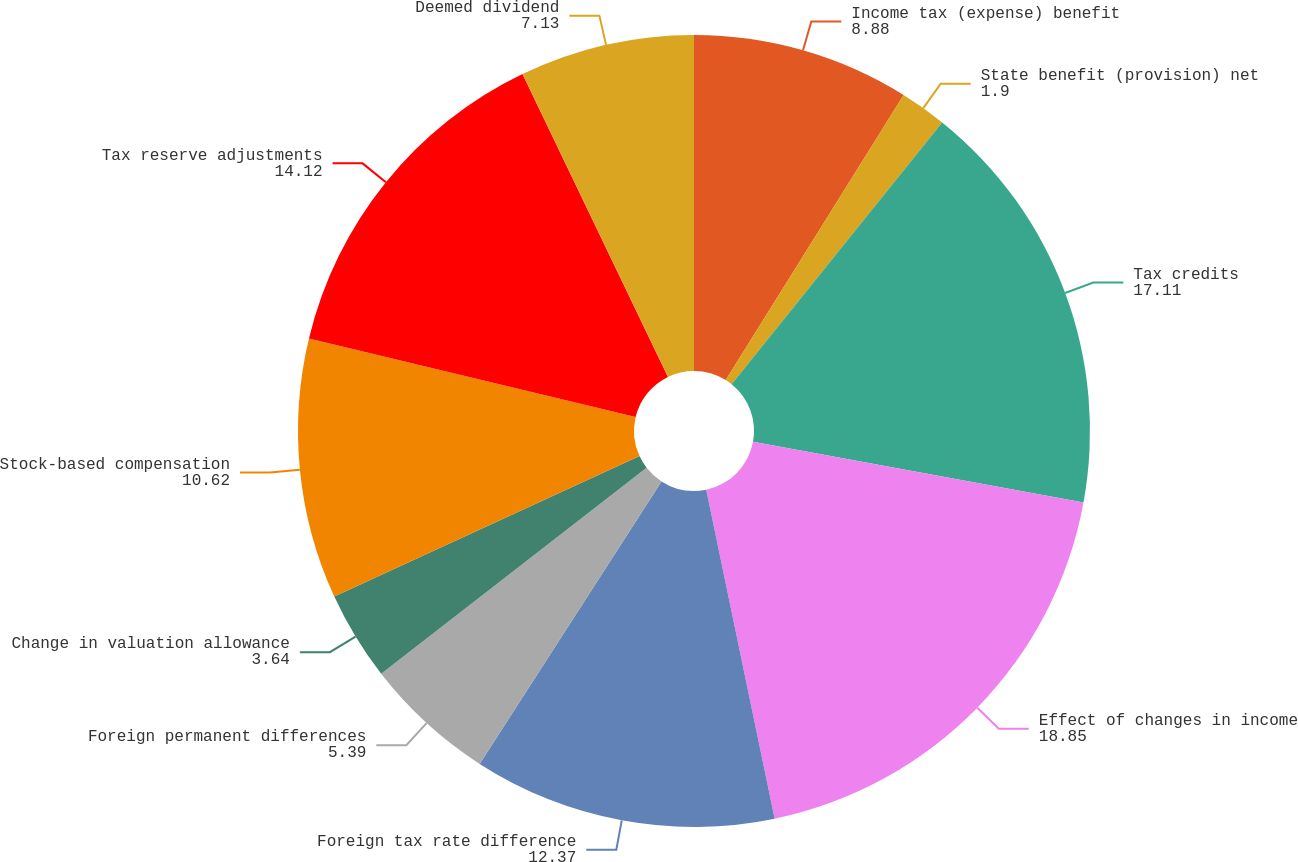<chart> <loc_0><loc_0><loc_500><loc_500><pie_chart><fcel>Income tax (expense) benefit<fcel>State benefit (provision) net<fcel>Tax credits<fcel>Effect of changes in income<fcel>Foreign tax rate difference<fcel>Foreign permanent differences<fcel>Change in valuation allowance<fcel>Stock-based compensation<fcel>Tax reserve adjustments<fcel>Deemed dividend<nl><fcel>8.88%<fcel>1.9%<fcel>17.11%<fcel>18.85%<fcel>12.37%<fcel>5.39%<fcel>3.64%<fcel>10.62%<fcel>14.12%<fcel>7.13%<nl></chart> 